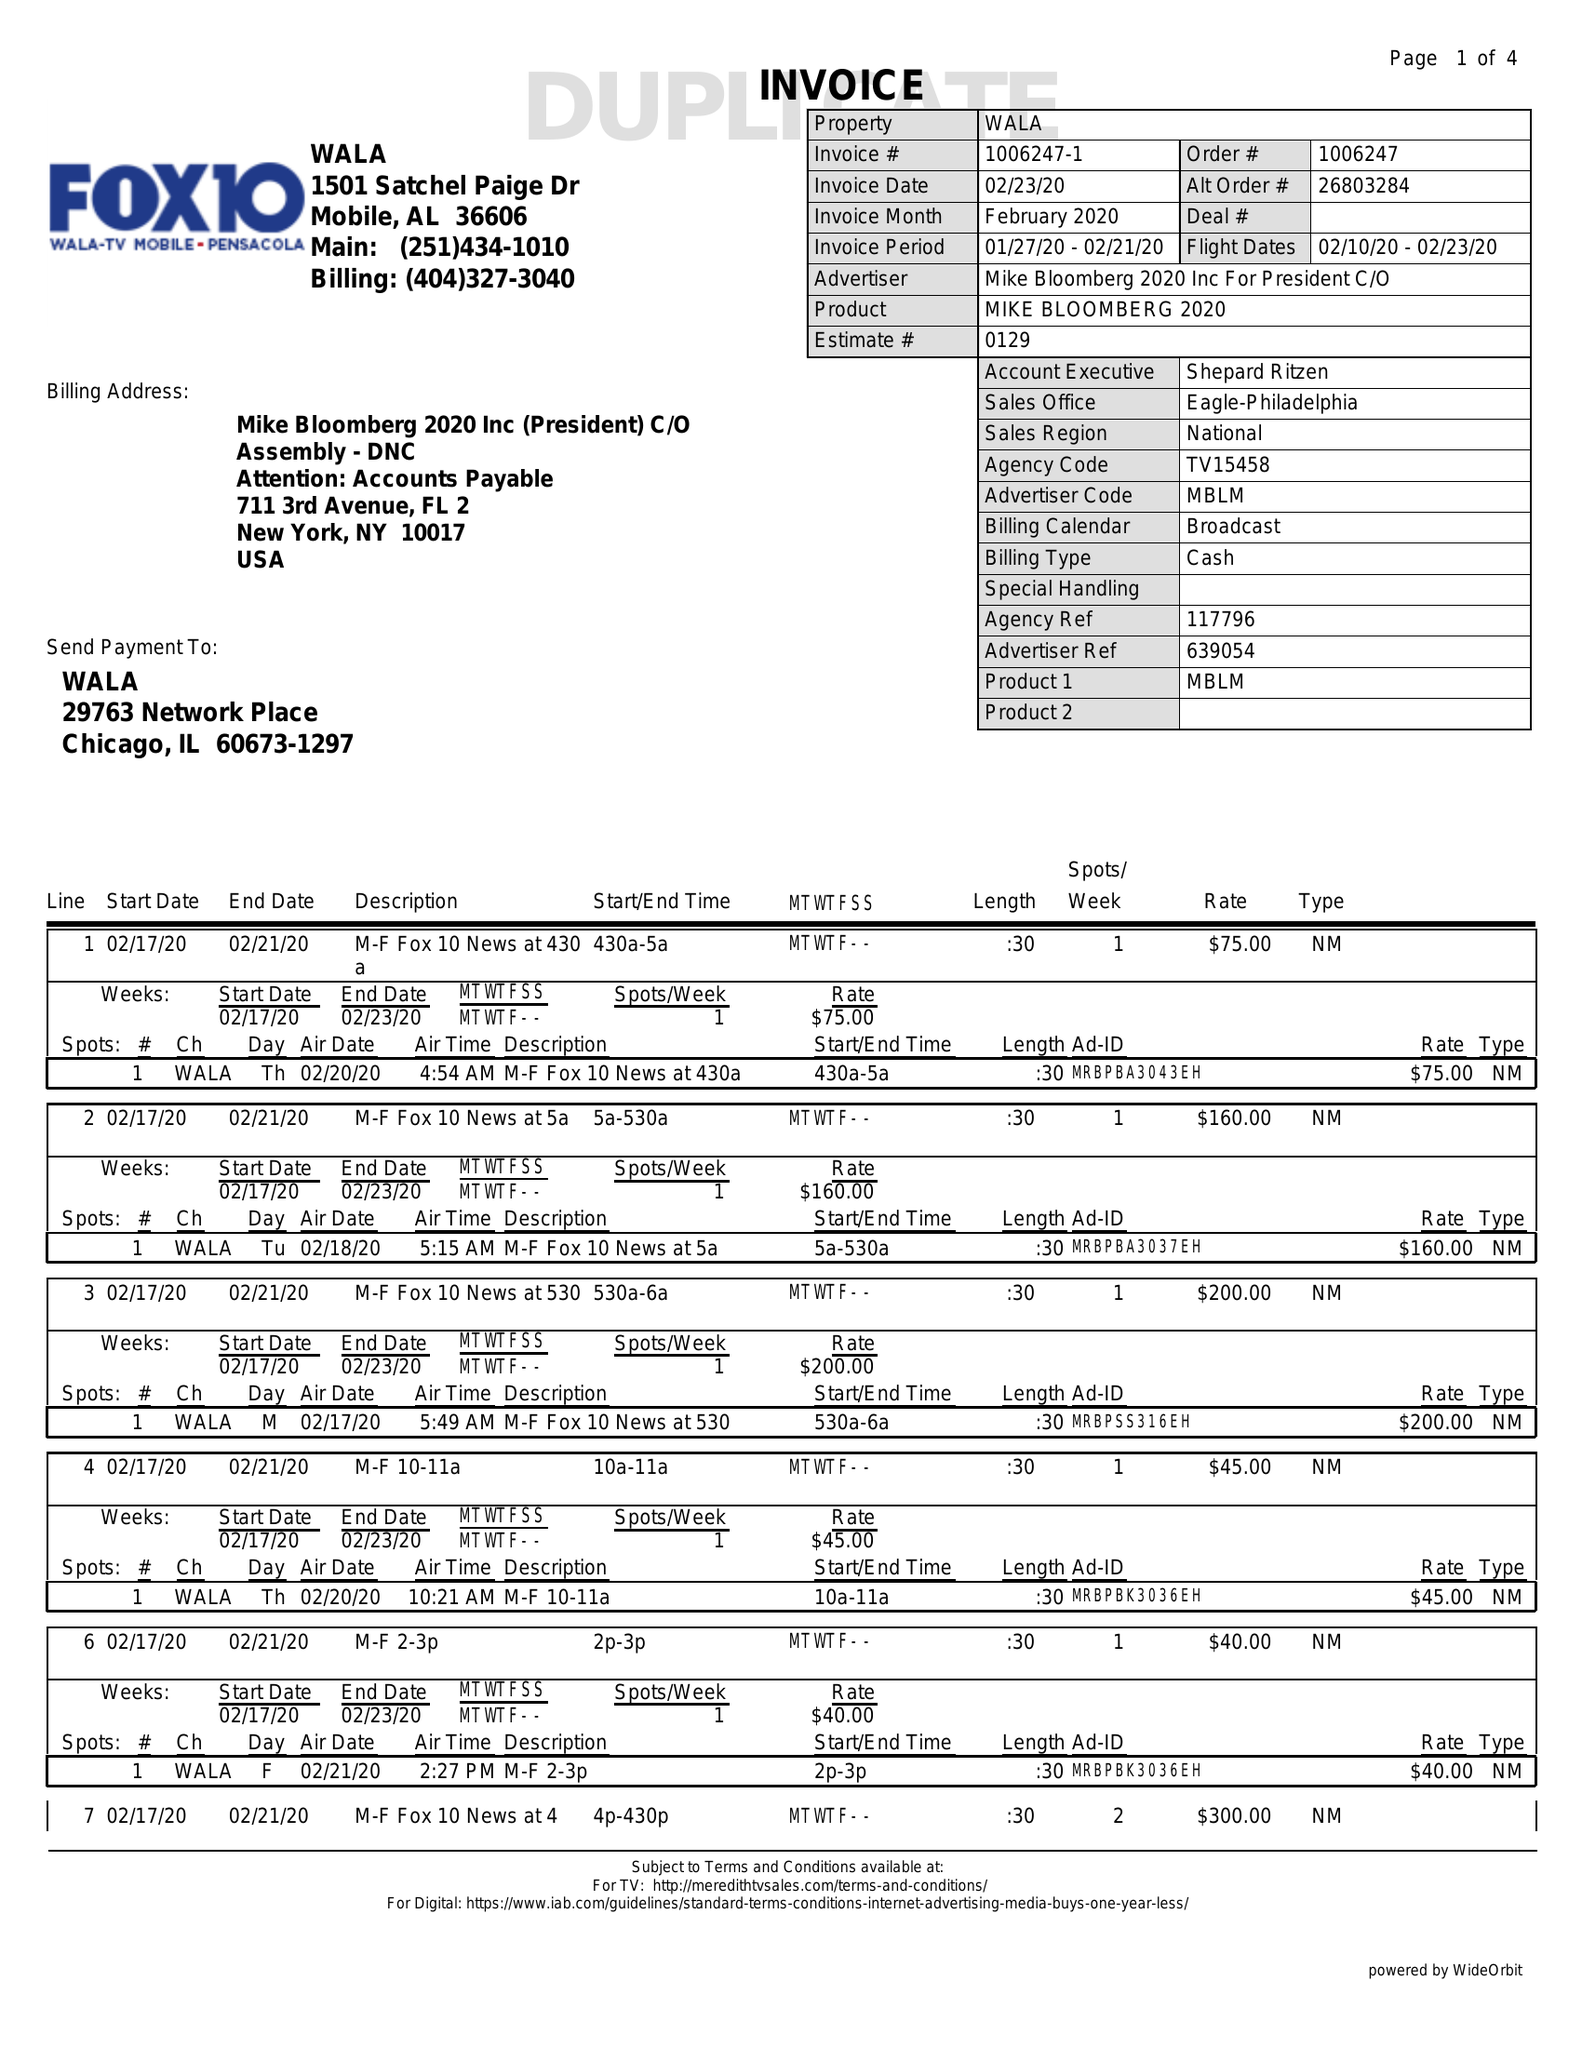What is the value for the gross_amount?
Answer the question using a single word or phrase. 6585.00 